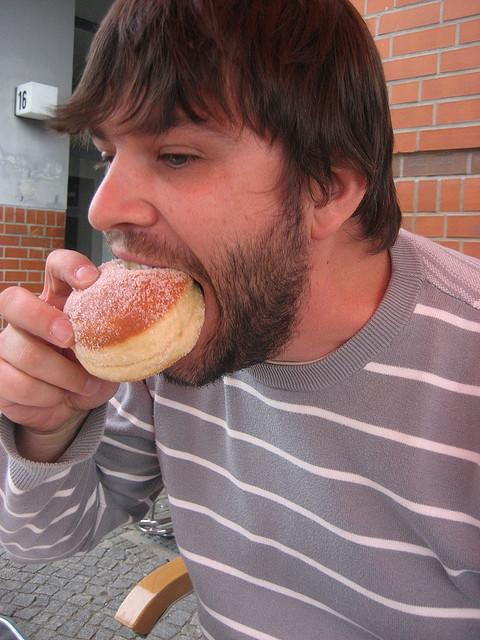Which character wears a shirt with a similar pattern to this man's shirt? Please explain your reasoning. linus. Linus has a striped shirt. 